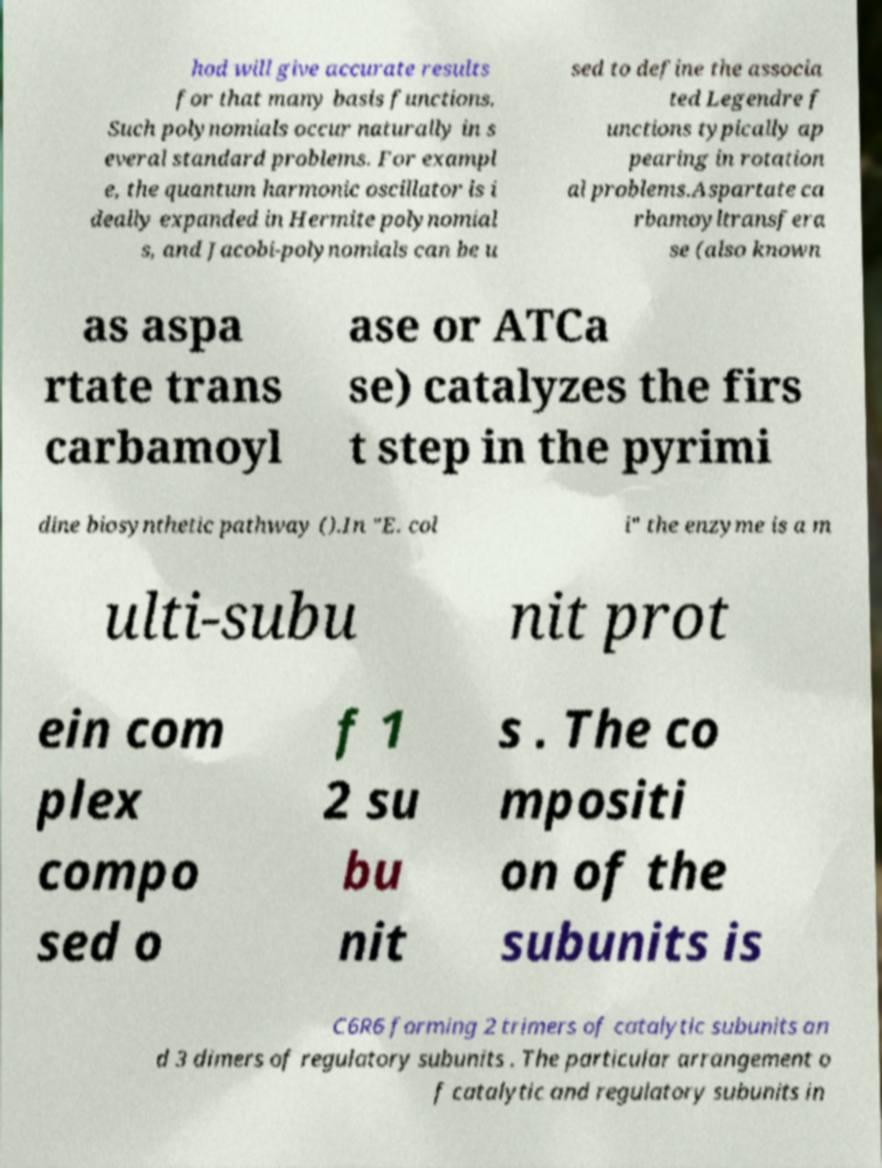Can you read and provide the text displayed in the image?This photo seems to have some interesting text. Can you extract and type it out for me? hod will give accurate results for that many basis functions. Such polynomials occur naturally in s everal standard problems. For exampl e, the quantum harmonic oscillator is i deally expanded in Hermite polynomial s, and Jacobi-polynomials can be u sed to define the associa ted Legendre f unctions typically ap pearing in rotation al problems.Aspartate ca rbamoyltransfera se (also known as aspa rtate trans carbamoyl ase or ATCa se) catalyzes the firs t step in the pyrimi dine biosynthetic pathway ().In "E. col i" the enzyme is a m ulti-subu nit prot ein com plex compo sed o f 1 2 su bu nit s . The co mpositi on of the subunits is C6R6 forming 2 trimers of catalytic subunits an d 3 dimers of regulatory subunits . The particular arrangement o f catalytic and regulatory subunits in 